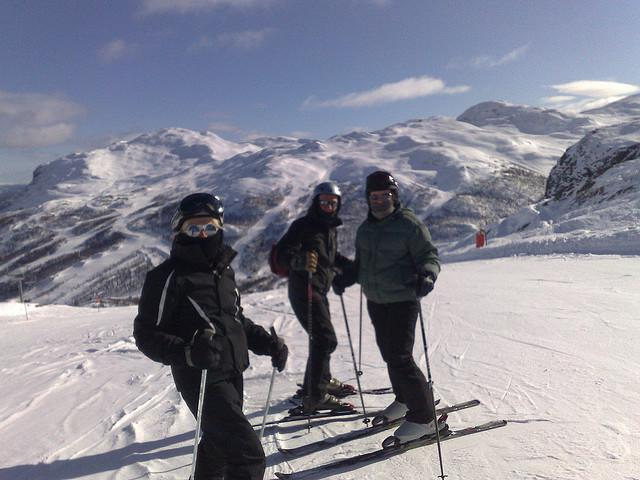Why are these people covering their faces? cold 